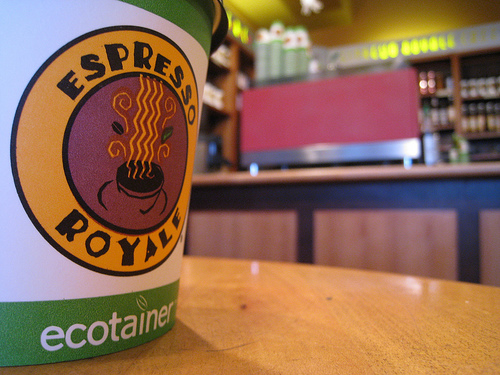<image>
Is the logo in the cup? Yes. The logo is contained within or inside the cup, showing a containment relationship. 